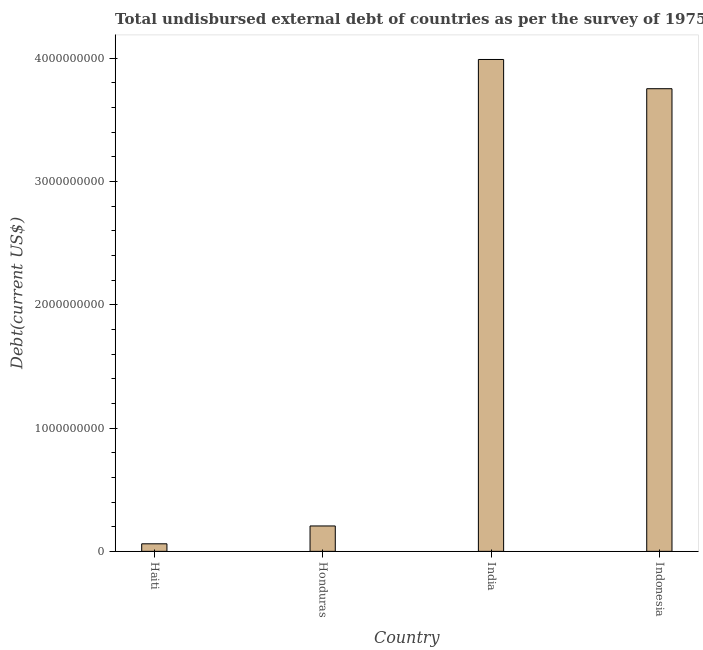Does the graph contain any zero values?
Your answer should be compact. No. Does the graph contain grids?
Offer a terse response. No. What is the title of the graph?
Your answer should be compact. Total undisbursed external debt of countries as per the survey of 1975. What is the label or title of the Y-axis?
Make the answer very short. Debt(current US$). What is the total debt in Haiti?
Give a very brief answer. 6.12e+07. Across all countries, what is the maximum total debt?
Your response must be concise. 3.99e+09. Across all countries, what is the minimum total debt?
Provide a short and direct response. 6.12e+07. In which country was the total debt minimum?
Provide a short and direct response. Haiti. What is the sum of the total debt?
Your answer should be very brief. 8.01e+09. What is the difference between the total debt in Honduras and India?
Your answer should be very brief. -3.78e+09. What is the average total debt per country?
Provide a succinct answer. 2.00e+09. What is the median total debt?
Keep it short and to the point. 1.98e+09. What is the ratio of the total debt in Haiti to that in India?
Ensure brevity in your answer.  0.01. What is the difference between the highest and the second highest total debt?
Your answer should be compact. 2.37e+08. Is the sum of the total debt in Haiti and Indonesia greater than the maximum total debt across all countries?
Your answer should be very brief. No. What is the difference between the highest and the lowest total debt?
Ensure brevity in your answer.  3.93e+09. In how many countries, is the total debt greater than the average total debt taken over all countries?
Make the answer very short. 2. Are all the bars in the graph horizontal?
Your answer should be compact. No. How many countries are there in the graph?
Ensure brevity in your answer.  4. What is the Debt(current US$) in Haiti?
Your answer should be very brief. 6.12e+07. What is the Debt(current US$) in Honduras?
Ensure brevity in your answer.  2.06e+08. What is the Debt(current US$) in India?
Give a very brief answer. 3.99e+09. What is the Debt(current US$) of Indonesia?
Provide a succinct answer. 3.75e+09. What is the difference between the Debt(current US$) in Haiti and Honduras?
Give a very brief answer. -1.45e+08. What is the difference between the Debt(current US$) in Haiti and India?
Keep it short and to the point. -3.93e+09. What is the difference between the Debt(current US$) in Haiti and Indonesia?
Make the answer very short. -3.69e+09. What is the difference between the Debt(current US$) in Honduras and India?
Ensure brevity in your answer.  -3.78e+09. What is the difference between the Debt(current US$) in Honduras and Indonesia?
Provide a succinct answer. -3.55e+09. What is the difference between the Debt(current US$) in India and Indonesia?
Ensure brevity in your answer.  2.37e+08. What is the ratio of the Debt(current US$) in Haiti to that in Honduras?
Your response must be concise. 0.3. What is the ratio of the Debt(current US$) in Haiti to that in India?
Your response must be concise. 0.01. What is the ratio of the Debt(current US$) in Haiti to that in Indonesia?
Make the answer very short. 0.02. What is the ratio of the Debt(current US$) in Honduras to that in India?
Offer a terse response. 0.05. What is the ratio of the Debt(current US$) in Honduras to that in Indonesia?
Offer a terse response. 0.06. What is the ratio of the Debt(current US$) in India to that in Indonesia?
Keep it short and to the point. 1.06. 